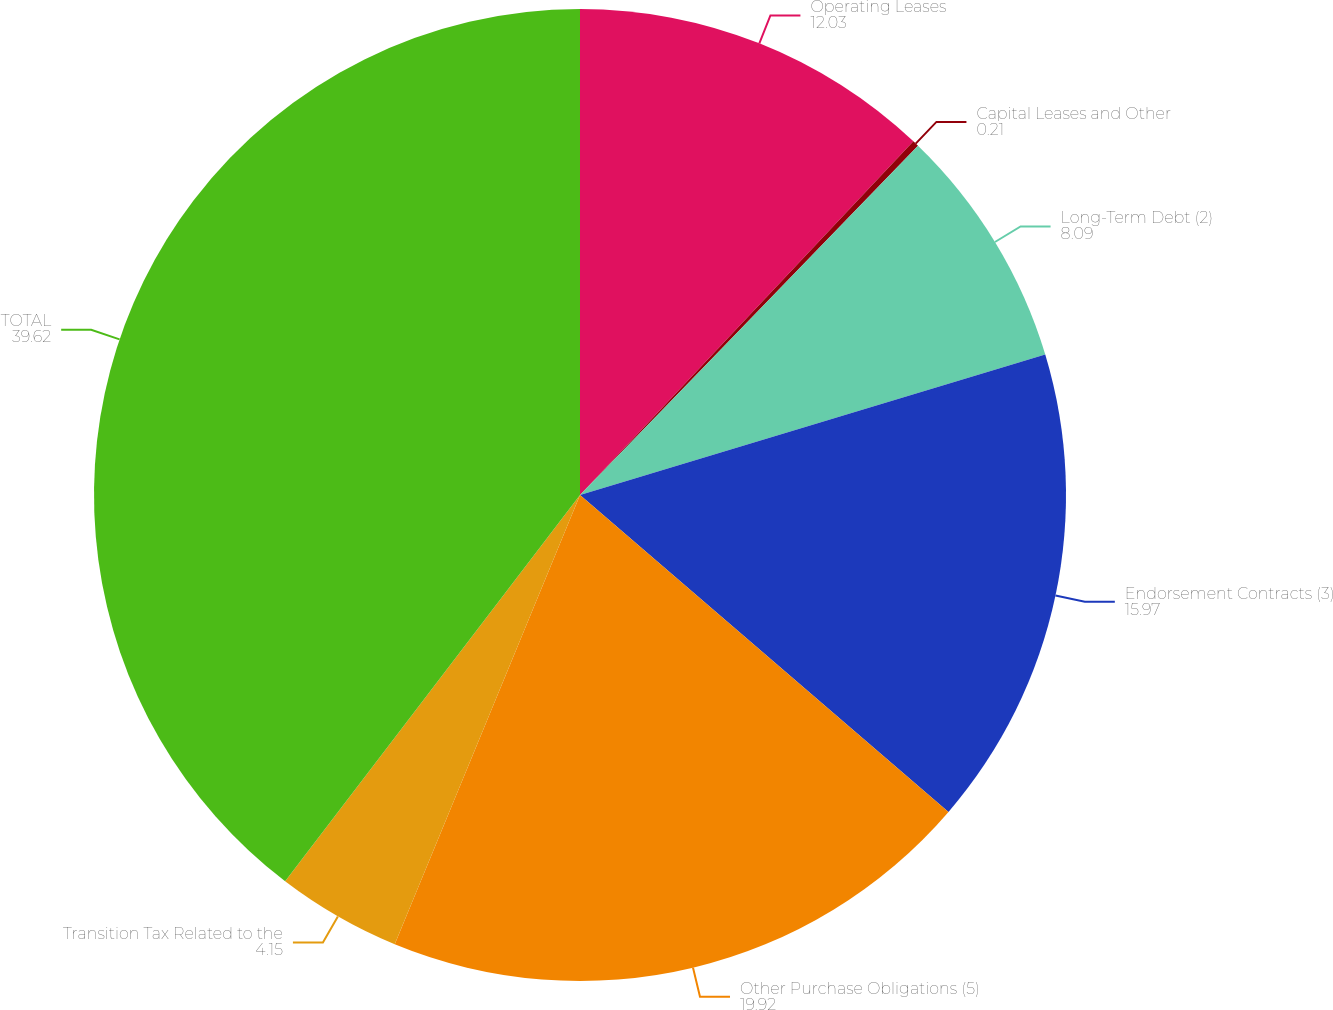<chart> <loc_0><loc_0><loc_500><loc_500><pie_chart><fcel>Operating Leases<fcel>Capital Leases and Other<fcel>Long-Term Debt (2)<fcel>Endorsement Contracts (3)<fcel>Other Purchase Obligations (5)<fcel>Transition Tax Related to the<fcel>TOTAL<nl><fcel>12.03%<fcel>0.21%<fcel>8.09%<fcel>15.97%<fcel>19.92%<fcel>4.15%<fcel>39.62%<nl></chart> 